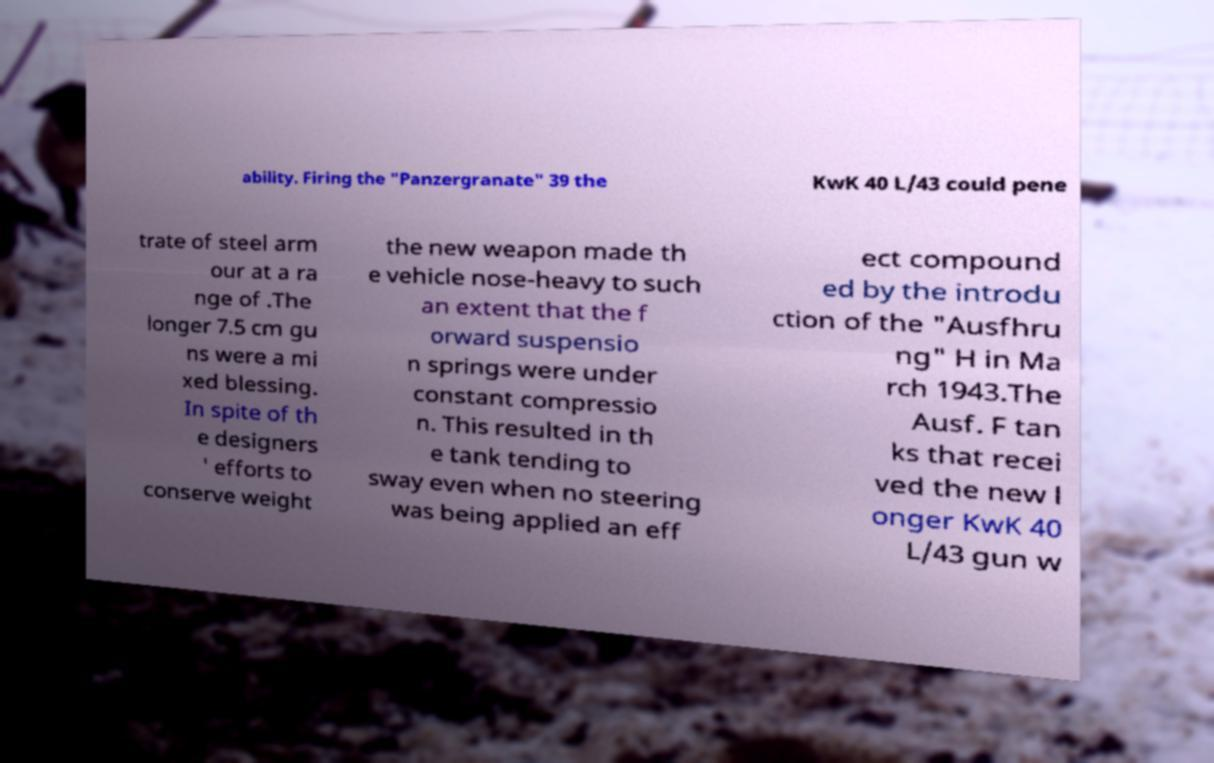For documentation purposes, I need the text within this image transcribed. Could you provide that? ability. Firing the "Panzergranate" 39 the KwK 40 L/43 could pene trate of steel arm our at a ra nge of .The longer 7.5 cm gu ns were a mi xed blessing. In spite of th e designers ' efforts to conserve weight the new weapon made th e vehicle nose-heavy to such an extent that the f orward suspensio n springs were under constant compressio n. This resulted in th e tank tending to sway even when no steering was being applied an eff ect compound ed by the introdu ction of the "Ausfhru ng" H in Ma rch 1943.The Ausf. F tan ks that recei ved the new l onger KwK 40 L/43 gun w 